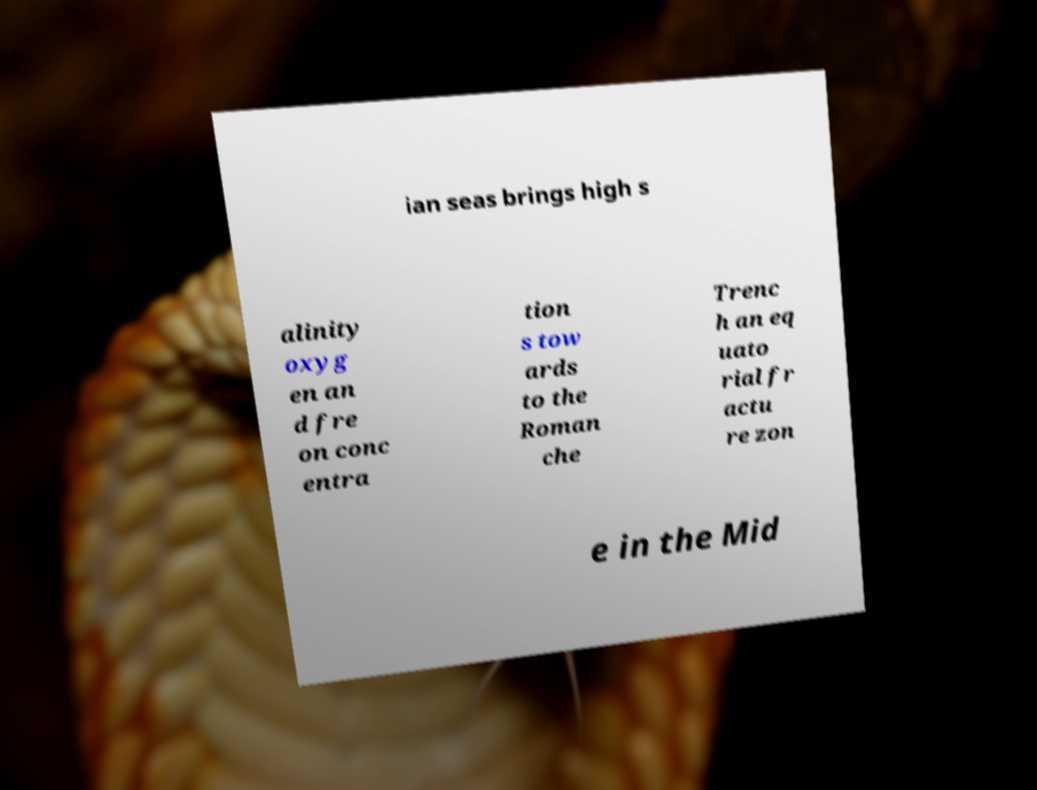There's text embedded in this image that I need extracted. Can you transcribe it verbatim? ian seas brings high s alinity oxyg en an d fre on conc entra tion s tow ards to the Roman che Trenc h an eq uato rial fr actu re zon e in the Mid 